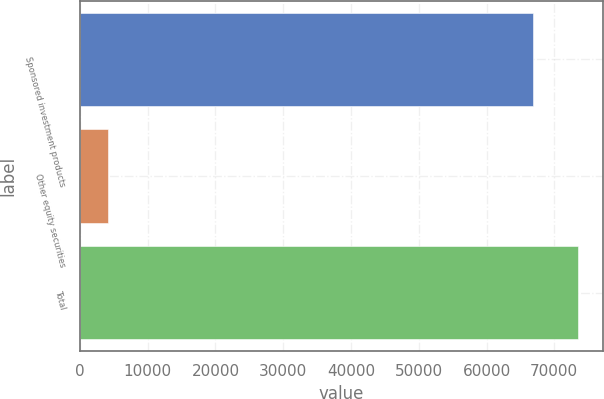<chart> <loc_0><loc_0><loc_500><loc_500><bar_chart><fcel>Sponsored investment products<fcel>Other equity securities<fcel>Total<nl><fcel>66816<fcel>4174<fcel>73497.6<nl></chart> 